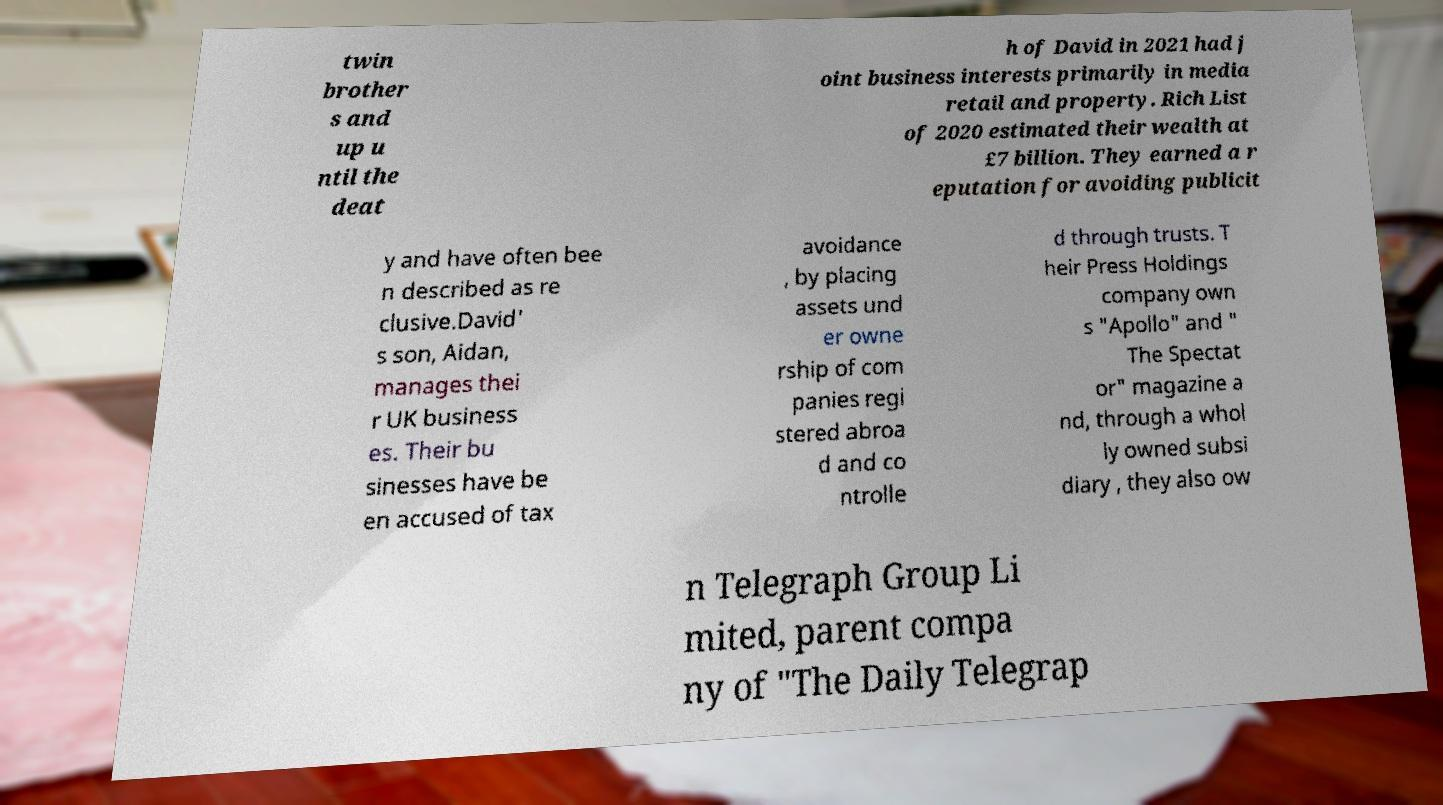Please identify and transcribe the text found in this image. twin brother s and up u ntil the deat h of David in 2021 had j oint business interests primarily in media retail and property. Rich List of 2020 estimated their wealth at £7 billion. They earned a r eputation for avoiding publicit y and have often bee n described as re clusive.David' s son, Aidan, manages thei r UK business es. Their bu sinesses have be en accused of tax avoidance , by placing assets und er owne rship of com panies regi stered abroa d and co ntrolle d through trusts. T heir Press Holdings company own s "Apollo" and " The Spectat or" magazine a nd, through a whol ly owned subsi diary , they also ow n Telegraph Group Li mited, parent compa ny of "The Daily Telegrap 